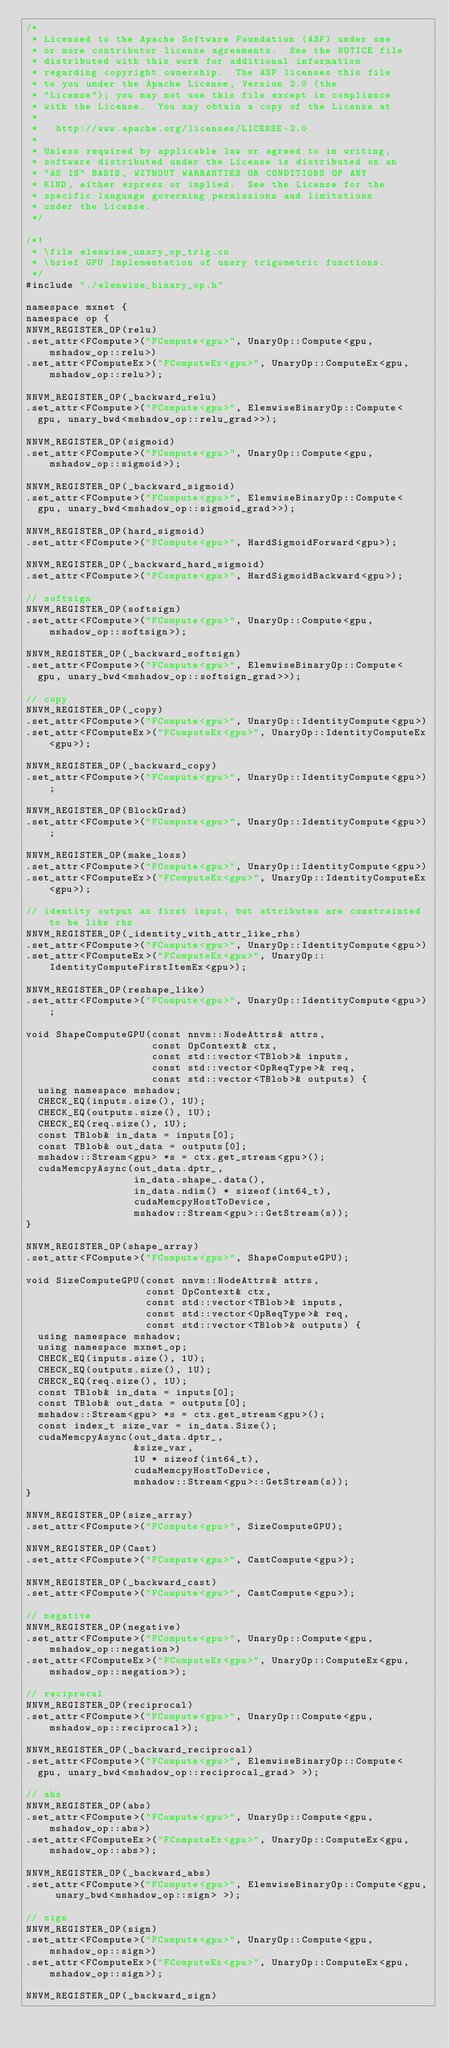Convert code to text. <code><loc_0><loc_0><loc_500><loc_500><_Cuda_>/*
 * Licensed to the Apache Software Foundation (ASF) under one
 * or more contributor license agreements.  See the NOTICE file
 * distributed with this work for additional information
 * regarding copyright ownership.  The ASF licenses this file
 * to you under the Apache License, Version 2.0 (the
 * "License"); you may not use this file except in compliance
 * with the License.  You may obtain a copy of the License at
 *
 *   http://www.apache.org/licenses/LICENSE-2.0
 *
 * Unless required by applicable law or agreed to in writing,
 * software distributed under the License is distributed on an
 * "AS IS" BASIS, WITHOUT WARRANTIES OR CONDITIONS OF ANY
 * KIND, either express or implied.  See the License for the
 * specific language governing permissions and limitations
 * under the License.
 */

/*!
 * \file elemwise_unary_op_trig.cu
 * \brief GPU Implementation of unary trigometric functions.
 */
#include "./elemwise_binary_op.h"

namespace mxnet {
namespace op {
NNVM_REGISTER_OP(relu)
.set_attr<FCompute>("FCompute<gpu>", UnaryOp::Compute<gpu, mshadow_op::relu>)
.set_attr<FComputeEx>("FComputeEx<gpu>", UnaryOp::ComputeEx<gpu, mshadow_op::relu>);

NNVM_REGISTER_OP(_backward_relu)
.set_attr<FCompute>("FCompute<gpu>", ElemwiseBinaryOp::Compute<
  gpu, unary_bwd<mshadow_op::relu_grad>>);

NNVM_REGISTER_OP(sigmoid)
.set_attr<FCompute>("FCompute<gpu>", UnaryOp::Compute<gpu, mshadow_op::sigmoid>);

NNVM_REGISTER_OP(_backward_sigmoid)
.set_attr<FCompute>("FCompute<gpu>", ElemwiseBinaryOp::Compute<
  gpu, unary_bwd<mshadow_op::sigmoid_grad>>);

NNVM_REGISTER_OP(hard_sigmoid)
.set_attr<FCompute>("FCompute<gpu>", HardSigmoidForward<gpu>);

NNVM_REGISTER_OP(_backward_hard_sigmoid)
.set_attr<FCompute>("FCompute<gpu>", HardSigmoidBackward<gpu>);

// softsign
NNVM_REGISTER_OP(softsign)
.set_attr<FCompute>("FCompute<gpu>", UnaryOp::Compute<gpu, mshadow_op::softsign>);

NNVM_REGISTER_OP(_backward_softsign)
.set_attr<FCompute>("FCompute<gpu>", ElemwiseBinaryOp::Compute<
  gpu, unary_bwd<mshadow_op::softsign_grad>>);

// copy
NNVM_REGISTER_OP(_copy)
.set_attr<FCompute>("FCompute<gpu>", UnaryOp::IdentityCompute<gpu>)
.set_attr<FComputeEx>("FComputeEx<gpu>", UnaryOp::IdentityComputeEx<gpu>);

NNVM_REGISTER_OP(_backward_copy)
.set_attr<FCompute>("FCompute<gpu>", UnaryOp::IdentityCompute<gpu>);

NNVM_REGISTER_OP(BlockGrad)
.set_attr<FCompute>("FCompute<gpu>", UnaryOp::IdentityCompute<gpu>);

NNVM_REGISTER_OP(make_loss)
.set_attr<FCompute>("FCompute<gpu>", UnaryOp::IdentityCompute<gpu>)
.set_attr<FComputeEx>("FComputeEx<gpu>", UnaryOp::IdentityComputeEx<gpu>);

// identity output as first input, but attributes are constrainted to be like rhs
NNVM_REGISTER_OP(_identity_with_attr_like_rhs)
.set_attr<FCompute>("FCompute<gpu>", UnaryOp::IdentityCompute<gpu>)
.set_attr<FComputeEx>("FComputeEx<gpu>", UnaryOp::IdentityComputeFirstItemEx<gpu>);

NNVM_REGISTER_OP(reshape_like)
.set_attr<FCompute>("FCompute<gpu>", UnaryOp::IdentityCompute<gpu>);

void ShapeComputeGPU(const nnvm::NodeAttrs& attrs,
                     const OpContext& ctx,
                     const std::vector<TBlob>& inputs,
                     const std::vector<OpReqType>& req,
                     const std::vector<TBlob>& outputs) {
  using namespace mshadow;
  CHECK_EQ(inputs.size(), 1U);
  CHECK_EQ(outputs.size(), 1U);
  CHECK_EQ(req.size(), 1U);
  const TBlob& in_data = inputs[0];
  const TBlob& out_data = outputs[0];
  mshadow::Stream<gpu> *s = ctx.get_stream<gpu>();
  cudaMemcpyAsync(out_data.dptr_,
                  in_data.shape_.data(),
                  in_data.ndim() * sizeof(int64_t),
                  cudaMemcpyHostToDevice,
                  mshadow::Stream<gpu>::GetStream(s));
}

NNVM_REGISTER_OP(shape_array)
.set_attr<FCompute>("FCompute<gpu>", ShapeComputeGPU);

void SizeComputeGPU(const nnvm::NodeAttrs& attrs,
                    const OpContext& ctx,
                    const std::vector<TBlob>& inputs,
                    const std::vector<OpReqType>& req,
                    const std::vector<TBlob>& outputs) {
  using namespace mshadow;
  using namespace mxnet_op;
  CHECK_EQ(inputs.size(), 1U);
  CHECK_EQ(outputs.size(), 1U);
  CHECK_EQ(req.size(), 1U);
  const TBlob& in_data = inputs[0];
  const TBlob& out_data = outputs[0];
  mshadow::Stream<gpu> *s = ctx.get_stream<gpu>();
  const index_t size_var = in_data.Size();
  cudaMemcpyAsync(out_data.dptr_,
                  &size_var,
                  1U * sizeof(int64_t),
                  cudaMemcpyHostToDevice,
                  mshadow::Stream<gpu>::GetStream(s));
}

NNVM_REGISTER_OP(size_array)
.set_attr<FCompute>("FCompute<gpu>", SizeComputeGPU);

NNVM_REGISTER_OP(Cast)
.set_attr<FCompute>("FCompute<gpu>", CastCompute<gpu>);

NNVM_REGISTER_OP(_backward_cast)
.set_attr<FCompute>("FCompute<gpu>", CastCompute<gpu>);

// negative
NNVM_REGISTER_OP(negative)
.set_attr<FCompute>("FCompute<gpu>", UnaryOp::Compute<gpu, mshadow_op::negation>)
.set_attr<FComputeEx>("FComputeEx<gpu>", UnaryOp::ComputeEx<gpu, mshadow_op::negation>);

// reciprocal
NNVM_REGISTER_OP(reciprocal)
.set_attr<FCompute>("FCompute<gpu>", UnaryOp::Compute<gpu, mshadow_op::reciprocal>);

NNVM_REGISTER_OP(_backward_reciprocal)
.set_attr<FCompute>("FCompute<gpu>", ElemwiseBinaryOp::Compute<
  gpu, unary_bwd<mshadow_op::reciprocal_grad> >);

// abs
NNVM_REGISTER_OP(abs)
.set_attr<FCompute>("FCompute<gpu>", UnaryOp::Compute<gpu, mshadow_op::abs>)
.set_attr<FComputeEx>("FComputeEx<gpu>", UnaryOp::ComputeEx<gpu, mshadow_op::abs>);

NNVM_REGISTER_OP(_backward_abs)
.set_attr<FCompute>("FCompute<gpu>", ElemwiseBinaryOp::Compute<gpu, unary_bwd<mshadow_op::sign> >);

// sign
NNVM_REGISTER_OP(sign)
.set_attr<FCompute>("FCompute<gpu>", UnaryOp::Compute<gpu, mshadow_op::sign>)
.set_attr<FComputeEx>("FComputeEx<gpu>", UnaryOp::ComputeEx<gpu, mshadow_op::sign>);

NNVM_REGISTER_OP(_backward_sign)</code> 